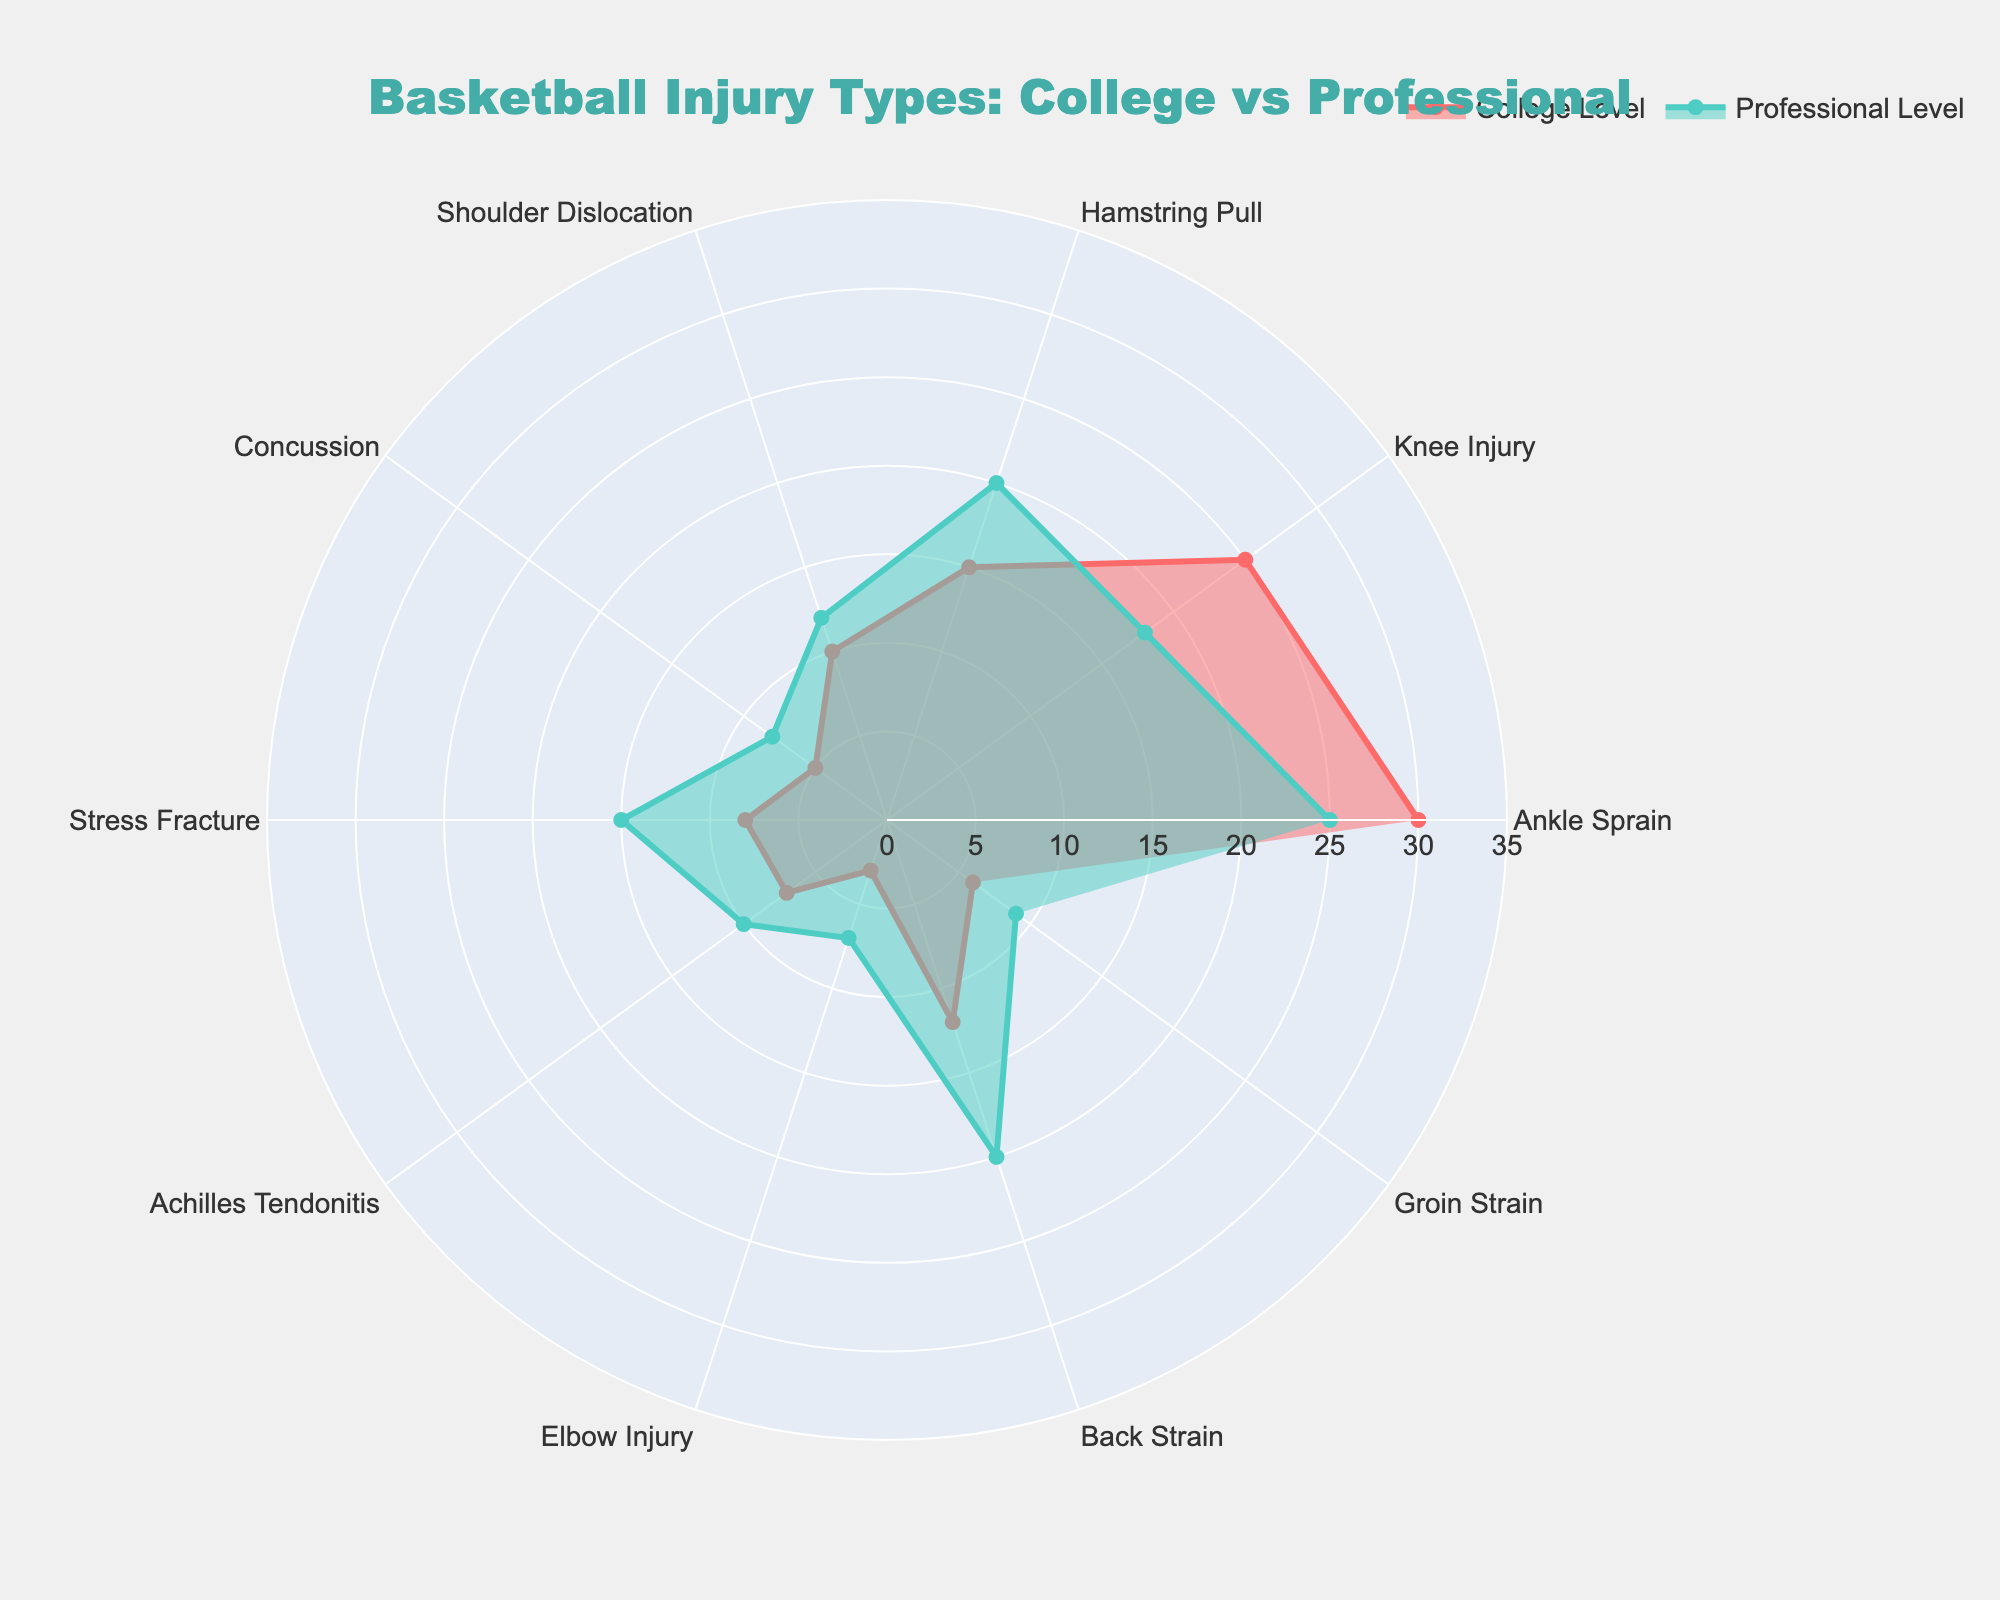What's the title of the plot? The title is usually placed at the top of the plot and is meant to provide a quick understanding of what the plot is about. In this case, the title is given in the code part where it specifies the figure's title.
Answer: Basketball Injury Types: College vs Professional Which injury type is most frequent at the college level? The injury type that extends the farthest along the radial axis in the college level series is the one that is most frequent. By examining the plot, this would be the Ankle Sprain with the highest value.
Answer: Ankle Sprain How does the frequency of knee injuries compare between college and professional levels? To compare knee injuries, observe the values for the Knee Injury category in both levels. The plot shows Knee Injury at 25 for College Level and 18 for Professional Level. Thus, knee injuries are more frequent at the college level.
Answer: More frequent at the college level Which injury type increases the most when comparing college to professional levels? To find the injury type that increases the most, calculate the difference for each injury type by subtracting the college level value from the professional level value. The injury type with the largest positive difference is the one that increases the most.
Answer: Stress Fracture What are the injury types where the professional level has higher frequencies than the college level? Look for injury types where the professional level value is greater than the corresponding college level value. The plot indicates these would be Hamstring Pull, Shoulder Dislocation, Concussion, Stress Fracture, Achilles Tendonitis, Elbow Injury, Back Strain, and Groin Strain.
Answer: Hamstring Pull, Shoulder Dislocation, Concussion, Stress Fracture, Achilles Tendonitis, Elbow Injury, Back Strain, Groin Strain Which injury type has the same frequency at both college and professional levels? To determine if any injury type has the same frequency, compare the values for each category at college and professional levels. The plot does not show any injury types with identical values at both levels, so there are none.
Answer: None What's the total number of different injury types represented in the plot? Count the unique categories listed in the 'Injury Type' axis of the radar chart. There are 10 different injury types displayed in the plot.
Answer: 10 How much more frequent are back strains at the professional level compared to the college level? Subtract the college level frequency of back strains from the professional level frequency. The values are 20 for Professional Level and 12 for College Level, so the difference is 20 - 12.
Answer: 8 What is the range of frequencies depicted on the radial axis? The radial axis represents the frequency of injuries, and its range can be identified by looking at the minimum and maximum values shown. The code specifies a range from 0 up to the greatest injury value plus 5, which would be 30 + 5 = 35.
Answer: 0 to 35 Which injury types have a frequency of 10 or below at both college and professional levels? Identify injury types where both the college and professional levels' frequencies are 10 or less. From the plot, these are Shoulder Dislocation, Concussion, Achilles Tendonitis, Elbow Injury, and Groin Strain.
Answer: Shoulder Dislocation, Concussion, Achilles Tendonitis, Elbow Injury, Groin Strain 